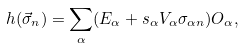Convert formula to latex. <formula><loc_0><loc_0><loc_500><loc_500>h ( \vec { \sigma } _ { n } ) = \sum _ { \alpha } ( E _ { \alpha } + s _ { \alpha } V _ { \alpha } \sigma _ { \alpha n } ) O _ { \alpha } ,</formula> 